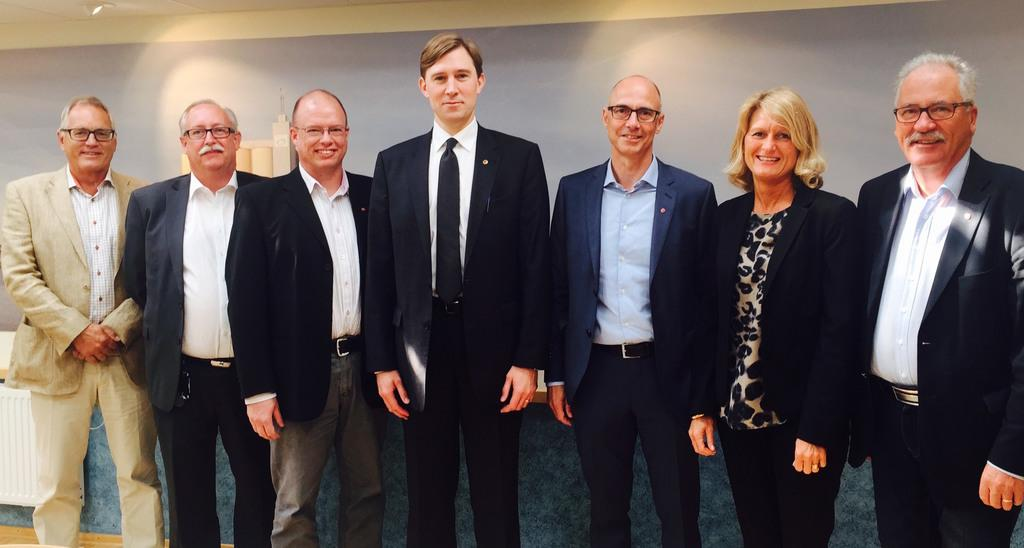How many people are in the image? There is a group of persons in the image. What are the persons wearing? The persons are wearing suits. Can you describe the woman in the image? The woman is wearing a blazer and is standing and posing for a photograph. What is visible in the background of the image? There is a wall in the background of the image. What type of destruction can be seen happening to the apples in the image? There are no apples present in the image, and therefore no destruction can be observed. 